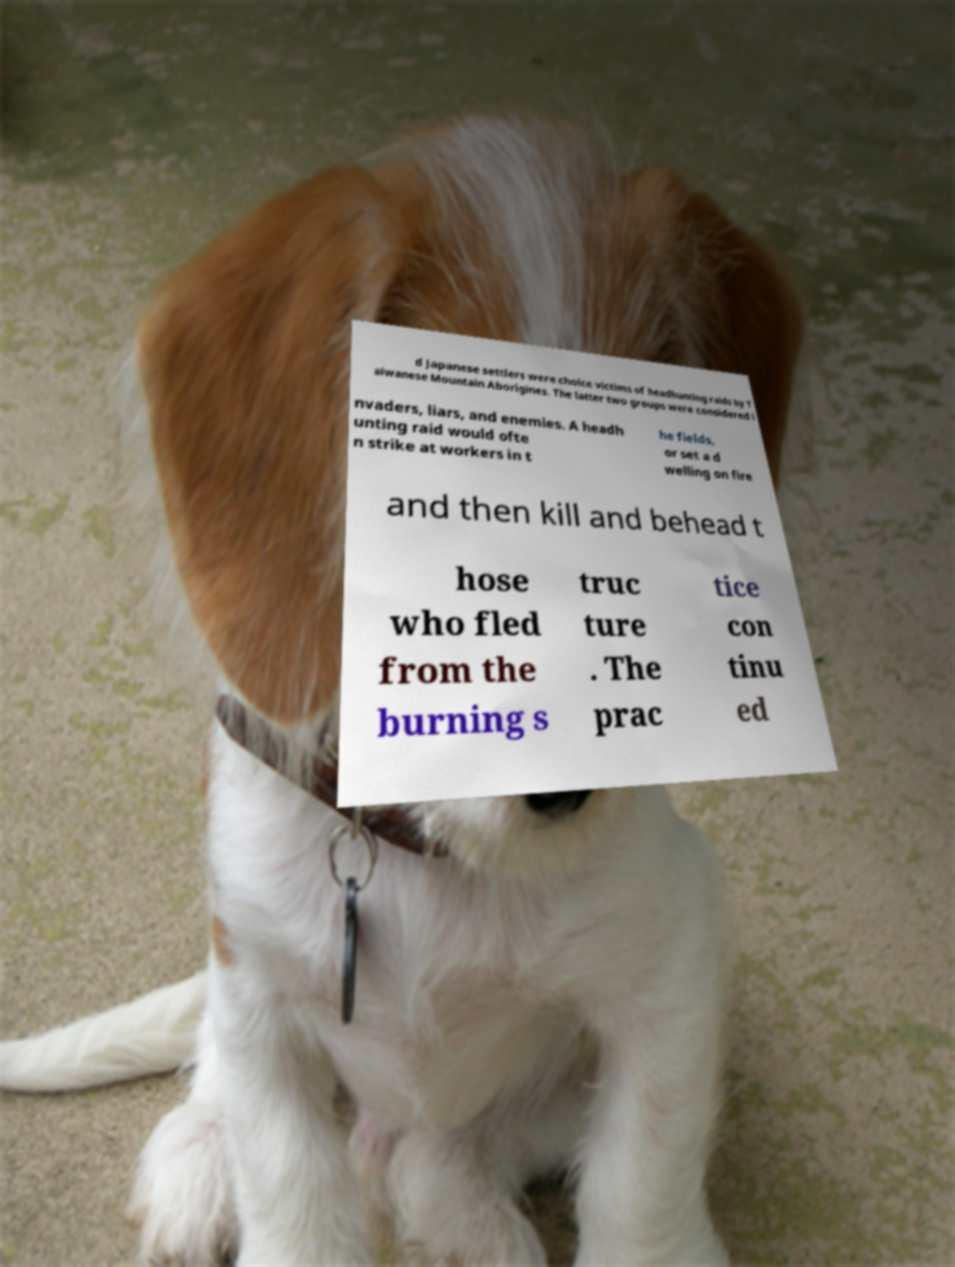Can you read and provide the text displayed in the image?This photo seems to have some interesting text. Can you extract and type it out for me? d Japanese settlers were choice victims of headhunting raids by T aiwanese Mountain Aborigines. The latter two groups were considered i nvaders, liars, and enemies. A headh unting raid would ofte n strike at workers in t he fields, or set a d welling on fire and then kill and behead t hose who fled from the burning s truc ture . The prac tice con tinu ed 